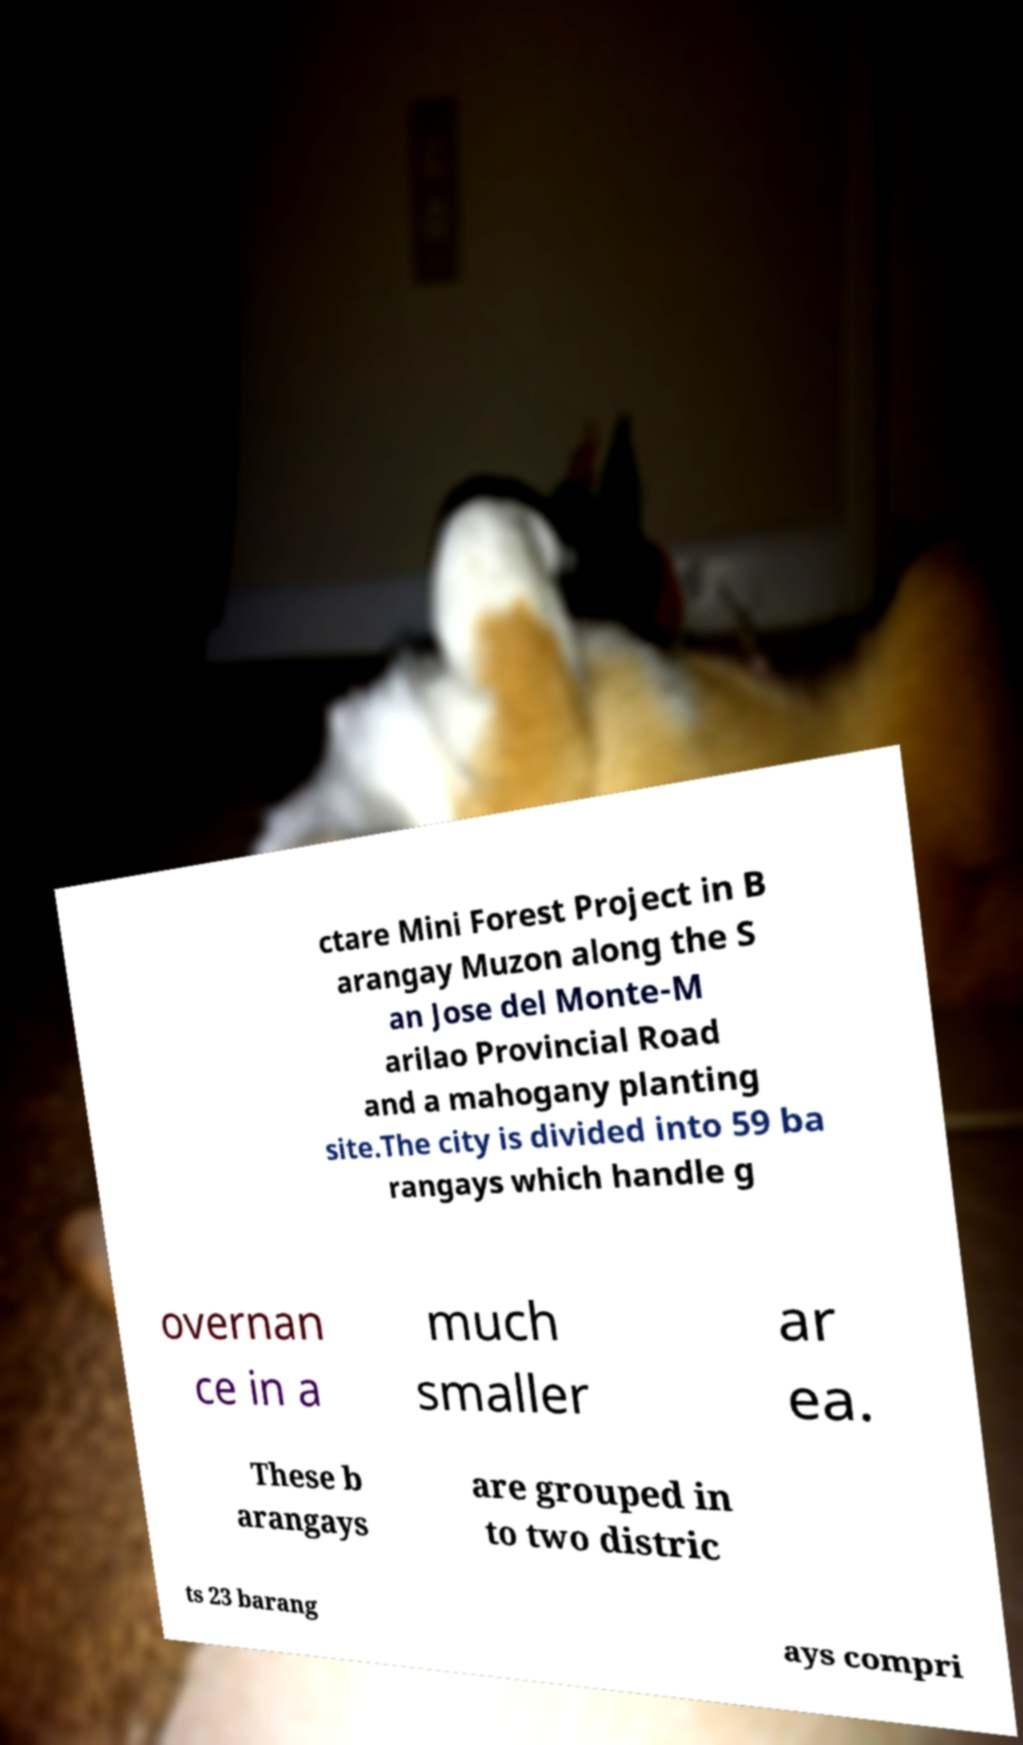Can you read and provide the text displayed in the image?This photo seems to have some interesting text. Can you extract and type it out for me? ctare Mini Forest Project in B arangay Muzon along the S an Jose del Monte-M arilao Provincial Road and a mahogany planting site.The city is divided into 59 ba rangays which handle g overnan ce in a much smaller ar ea. These b arangays are grouped in to two distric ts 23 barang ays compri 